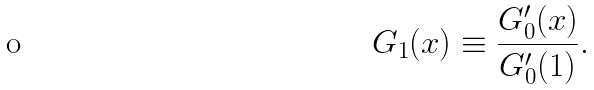Convert formula to latex. <formula><loc_0><loc_0><loc_500><loc_500>G _ { 1 } ( x ) \equiv \frac { G _ { 0 } ^ { \prime } ( x ) } { G _ { 0 } ^ { \prime } ( 1 ) } .</formula> 